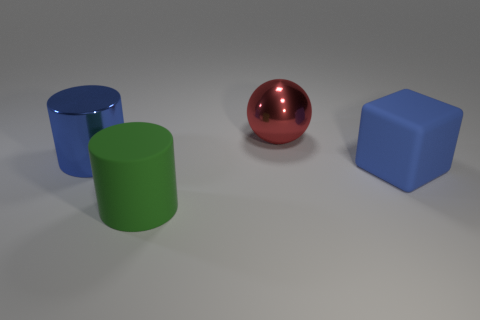Add 3 big blue shiny objects. How many objects exist? 7 Subtract all blue cubes. How many green cylinders are left? 1 Subtract all big gray metallic cylinders. Subtract all balls. How many objects are left? 3 Add 2 big blue things. How many big blue things are left? 4 Add 2 large shiny cylinders. How many large shiny cylinders exist? 3 Subtract 0 cyan blocks. How many objects are left? 4 Subtract all cubes. How many objects are left? 3 Subtract 2 cylinders. How many cylinders are left? 0 Subtract all yellow blocks. Subtract all purple cylinders. How many blocks are left? 1 